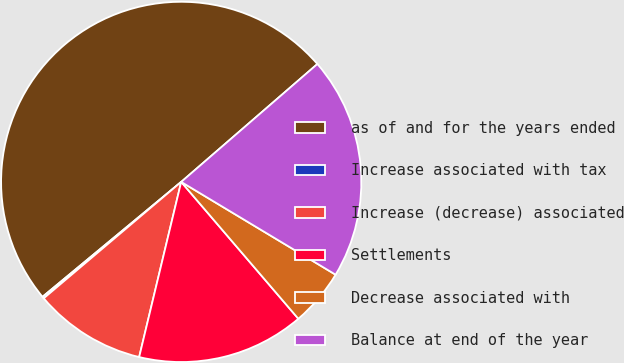Convert chart. <chart><loc_0><loc_0><loc_500><loc_500><pie_chart><fcel>as of and for the years ended<fcel>Increase associated with tax<fcel>Increase (decrease) associated<fcel>Settlements<fcel>Decrease associated with<fcel>Balance at end of the year<nl><fcel>49.66%<fcel>0.17%<fcel>10.07%<fcel>15.02%<fcel>5.12%<fcel>19.97%<nl></chart> 